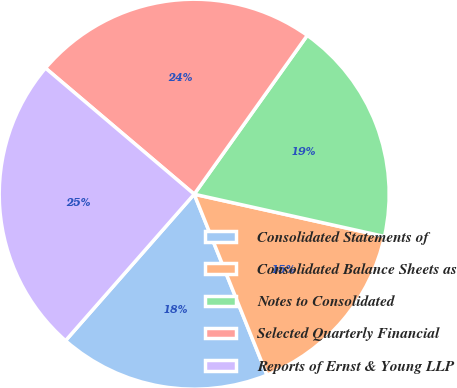<chart> <loc_0><loc_0><loc_500><loc_500><pie_chart><fcel>Consolidated Statements of<fcel>Consolidated Balance Sheets as<fcel>Notes to Consolidated<fcel>Selected Quarterly Financial<fcel>Reports of Ernst & Young LLP<nl><fcel>17.56%<fcel>15.43%<fcel>18.63%<fcel>23.65%<fcel>24.72%<nl></chart> 